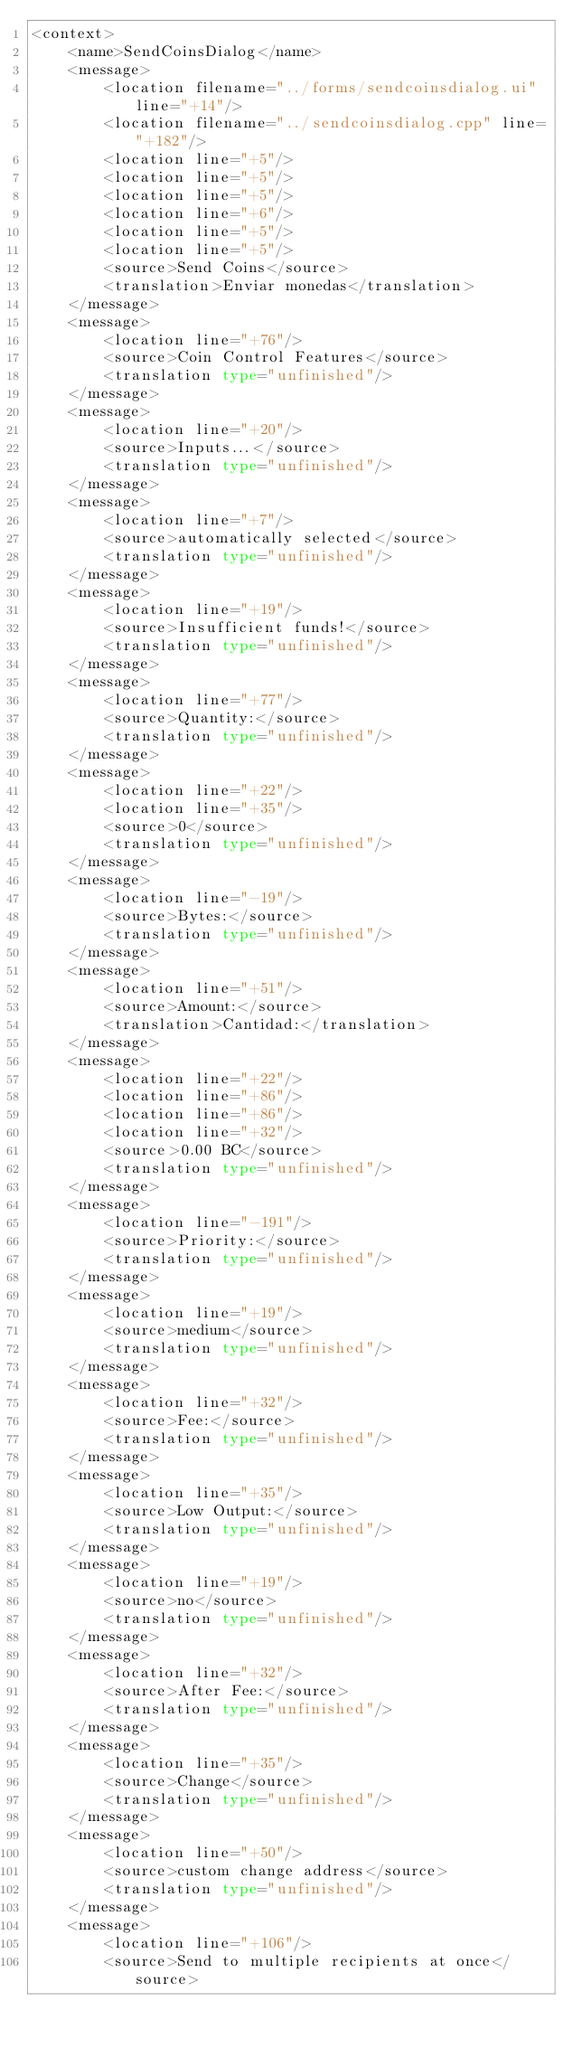<code> <loc_0><loc_0><loc_500><loc_500><_TypeScript_><context>
    <name>SendCoinsDialog</name>
    <message>
        <location filename="../forms/sendcoinsdialog.ui" line="+14"/>
        <location filename="../sendcoinsdialog.cpp" line="+182"/>
        <location line="+5"/>
        <location line="+5"/>
        <location line="+5"/>
        <location line="+6"/>
        <location line="+5"/>
        <location line="+5"/>
        <source>Send Coins</source>
        <translation>Enviar monedas</translation>
    </message>
    <message>
        <location line="+76"/>
        <source>Coin Control Features</source>
        <translation type="unfinished"/>
    </message>
    <message>
        <location line="+20"/>
        <source>Inputs...</source>
        <translation type="unfinished"/>
    </message>
    <message>
        <location line="+7"/>
        <source>automatically selected</source>
        <translation type="unfinished"/>
    </message>
    <message>
        <location line="+19"/>
        <source>Insufficient funds!</source>
        <translation type="unfinished"/>
    </message>
    <message>
        <location line="+77"/>
        <source>Quantity:</source>
        <translation type="unfinished"/>
    </message>
    <message>
        <location line="+22"/>
        <location line="+35"/>
        <source>0</source>
        <translation type="unfinished"/>
    </message>
    <message>
        <location line="-19"/>
        <source>Bytes:</source>
        <translation type="unfinished"/>
    </message>
    <message>
        <location line="+51"/>
        <source>Amount:</source>
        <translation>Cantidad:</translation>
    </message>
    <message>
        <location line="+22"/>
        <location line="+86"/>
        <location line="+86"/>
        <location line="+32"/>
        <source>0.00 BC</source>
        <translation type="unfinished"/>
    </message>
    <message>
        <location line="-191"/>
        <source>Priority:</source>
        <translation type="unfinished"/>
    </message>
    <message>
        <location line="+19"/>
        <source>medium</source>
        <translation type="unfinished"/>
    </message>
    <message>
        <location line="+32"/>
        <source>Fee:</source>
        <translation type="unfinished"/>
    </message>
    <message>
        <location line="+35"/>
        <source>Low Output:</source>
        <translation type="unfinished"/>
    </message>
    <message>
        <location line="+19"/>
        <source>no</source>
        <translation type="unfinished"/>
    </message>
    <message>
        <location line="+32"/>
        <source>After Fee:</source>
        <translation type="unfinished"/>
    </message>
    <message>
        <location line="+35"/>
        <source>Change</source>
        <translation type="unfinished"/>
    </message>
    <message>
        <location line="+50"/>
        <source>custom change address</source>
        <translation type="unfinished"/>
    </message>
    <message>
        <location line="+106"/>
        <source>Send to multiple recipients at once</source></code> 